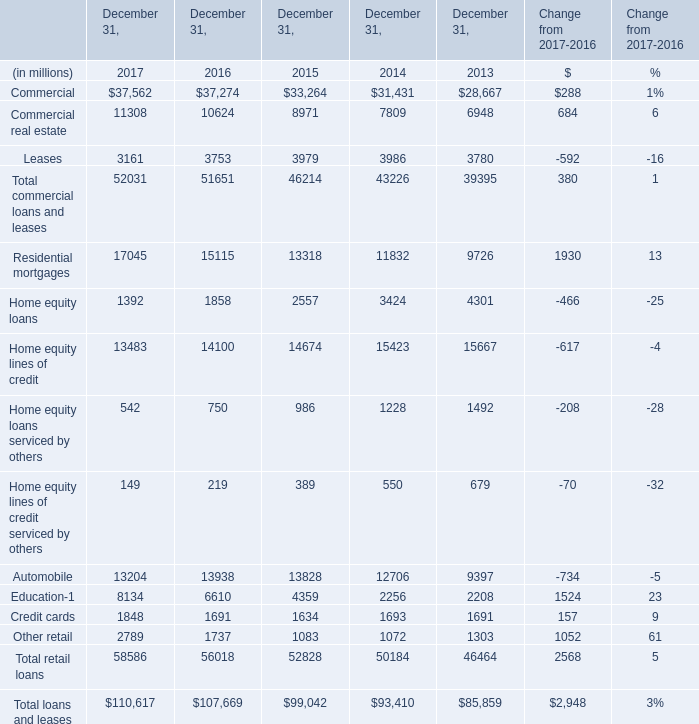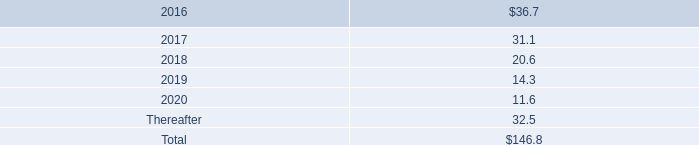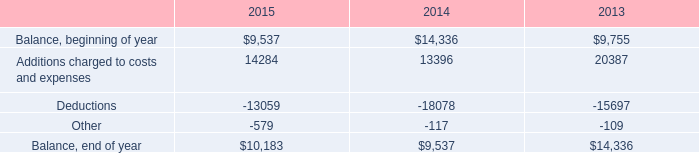What was the average of the Commercial and Commercial real estate in the years where Total retail loans is positive? (in million) 
Computations: ((37562 + 11308) / 2)
Answer: 24435.0. 